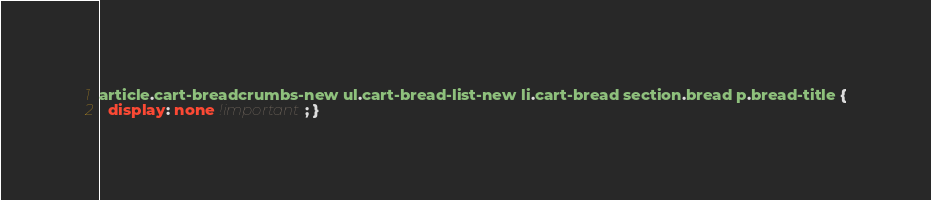<code> <loc_0><loc_0><loc_500><loc_500><_CSS_>article.cart-breadcrumbs-new ul.cart-bread-list-new li.cart-bread section.bread p.bread-title {
  display: none !important; }
</code> 